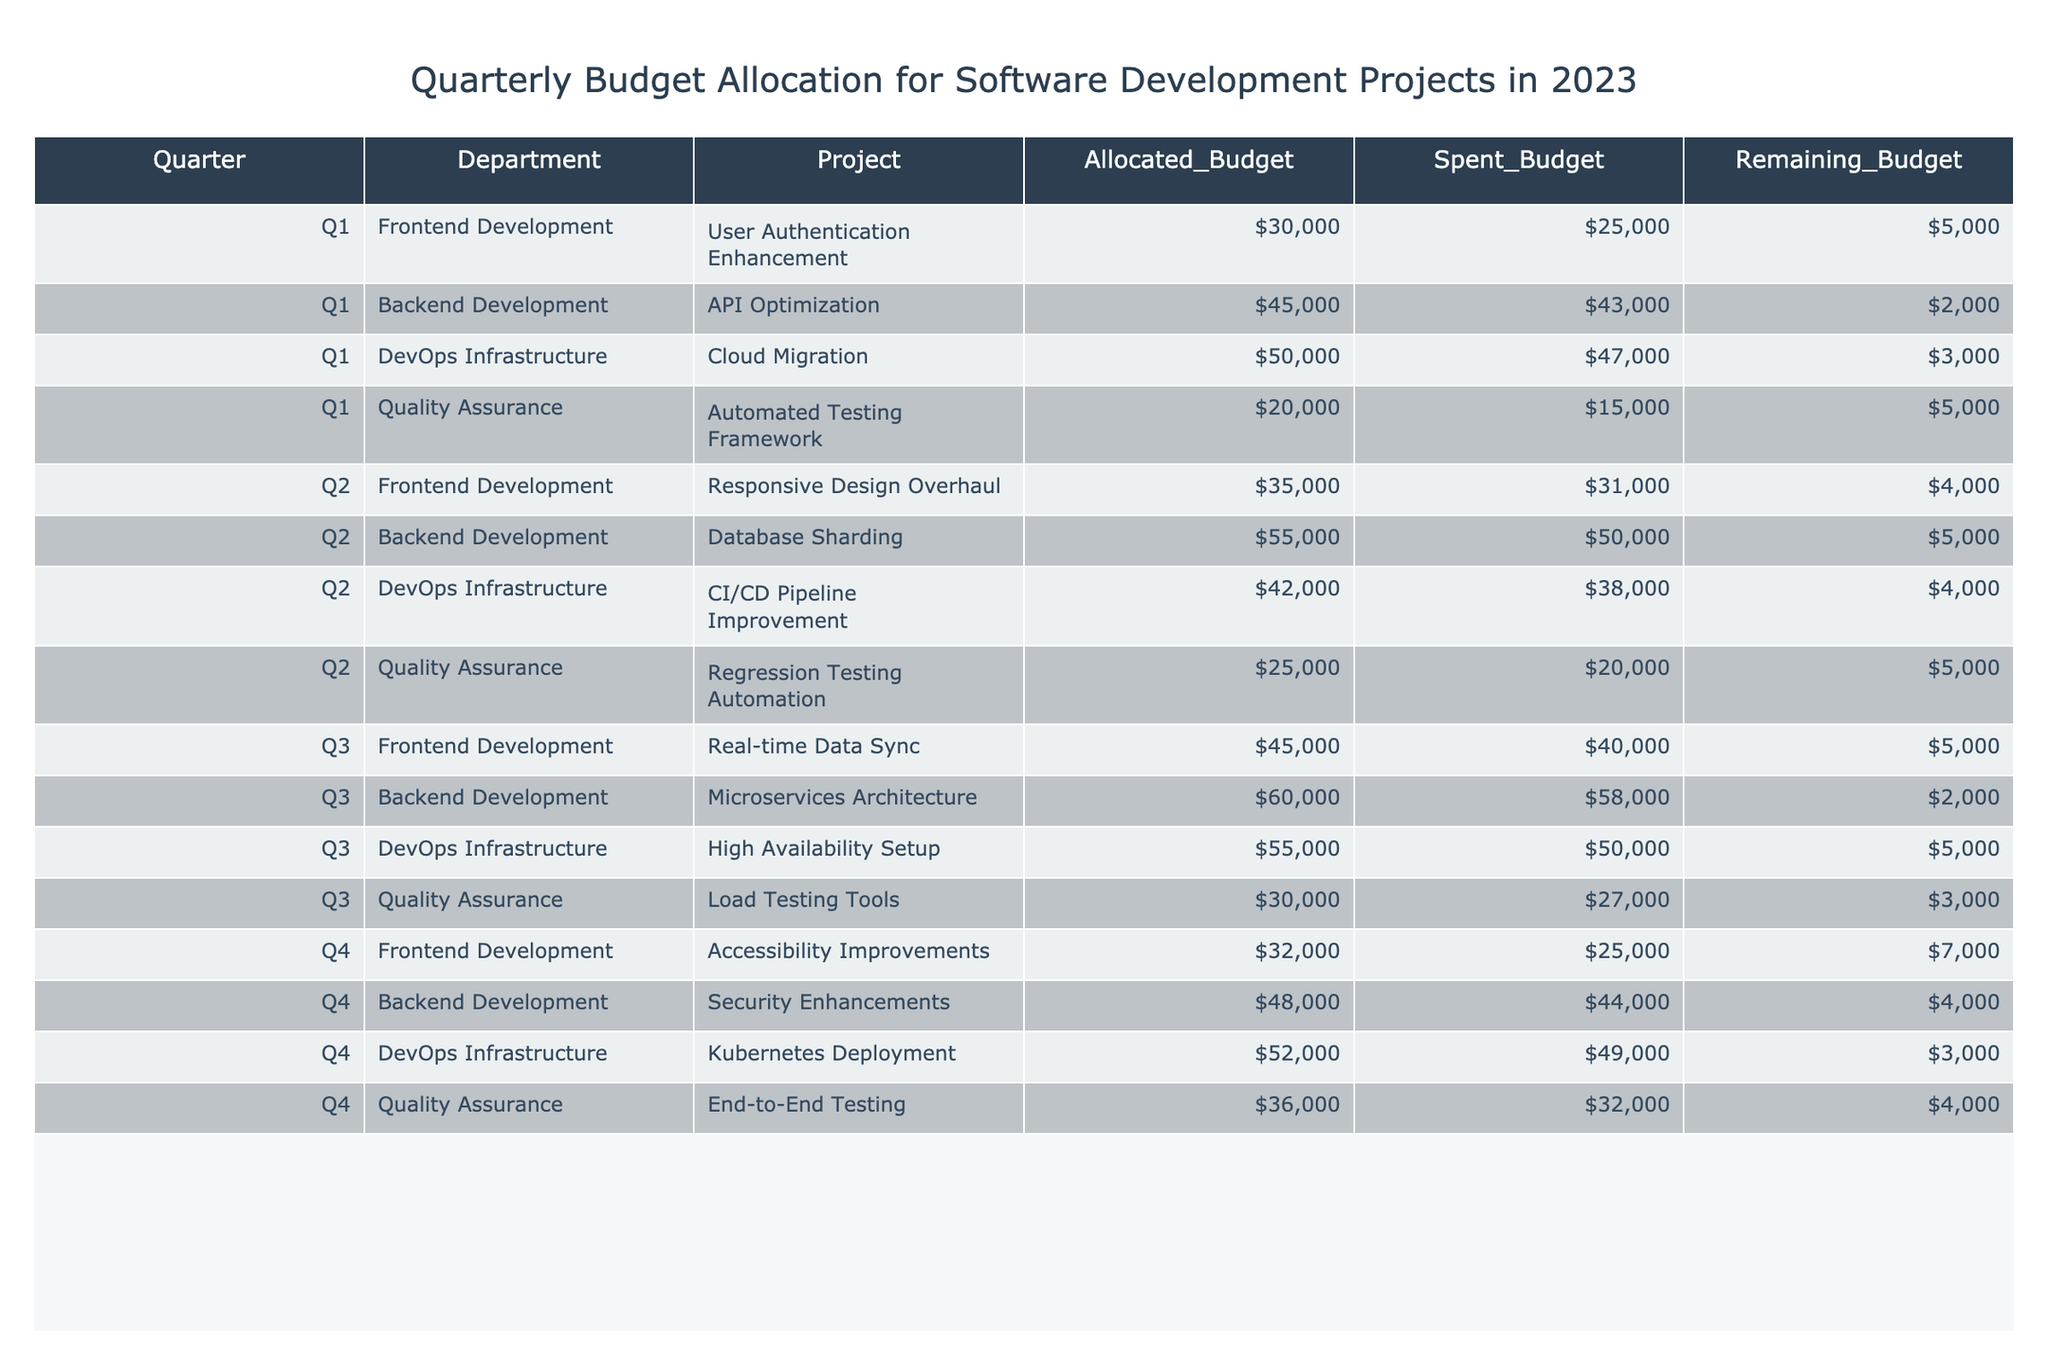What was the allocated budget for the Backend Development project in Q2? Referring to the table, the allocated budget for the Backend Development project (Database Sharding) in Q2 can be found in that row. The value is 55000.
Answer: 55000 What is the remaining budget for Quality Assurance in Q3? In the table, the remaining budget for the Quality Assurance project (Load Testing Tools) in Q3 is indicated in the respective row, which is 3000.
Answer: 3000 Which department had the highest total allocated budget across all quarters? To determine this, we can sum the allocated budgets for each department across all quarters: Frontend Development: 30000 + 35000 + 45000 + 32000 = 137000, Backend Development: 45000 + 55000 + 60000 + 48000 = 213000, DevOps Infrastructure: 50000 + 42000 + 55000 + 52000 = 199000, Quality Assurance: 20000 + 25000 + 30000 + 36000 = 111000. The highest total is for Backend Development with 213000.
Answer: Backend Development Did the Frontend Development project go over budget in Q1? For the Frontend Development project (User Authentication Enhancement) in Q1, the allocated budget is 30000 and the spent budget is 25000. Since the spent budget is less than the allocated budget, it did not go over budget.
Answer: No What was the total remaining budget for all projects in Q4? To find the total remaining budget in Q4, sum the remaining budgets for each project: Accessibility Improvements: 7000, Security Enhancements: 4000, Kubernetes Deployment: 3000, End-to-End Testing: 4000. The sum is 7000 + 4000 + 3000 + 4000 = 18000.
Answer: 18000 How much more was spent in Backend Development than in Quality Assurance in Q3? In Q3, the spent budget for Backend Development (Microservices Architecture) is 58000, and for Quality Assurance (Load Testing Tools) it is 27000. The difference is 58000 - 27000 = 31000.
Answer: 31000 Which project had the smallest remaining budget in Q2? To find this, we look at the remaining budgets for all projects in Q2: Responsive Design Overhaul: 4000, Database Sharding: 5000, CI/CD Pipeline Improvement: 4000, Regression Testing Automation: 5000. The smallest remaining budget is for the Responsive Design Overhaul and CI/CD Pipeline Improvement, both with 4000 remaining.
Answer: Responsive Design Overhaul and CI/CD Pipeline Improvement What is the average allocated budget for DevOps Infrastructure projects across the four quarters? The allocated budgets for DevOps Infrastructure are: Q1: 50000, Q2: 42000, Q3: 55000, Q4: 52000. The average is calculated by summing these values (50000 + 42000 + 55000 + 52000 = 199000) and then dividing by the number of projects (4). So, 199000 / 4 = 49750.
Answer: 49750 